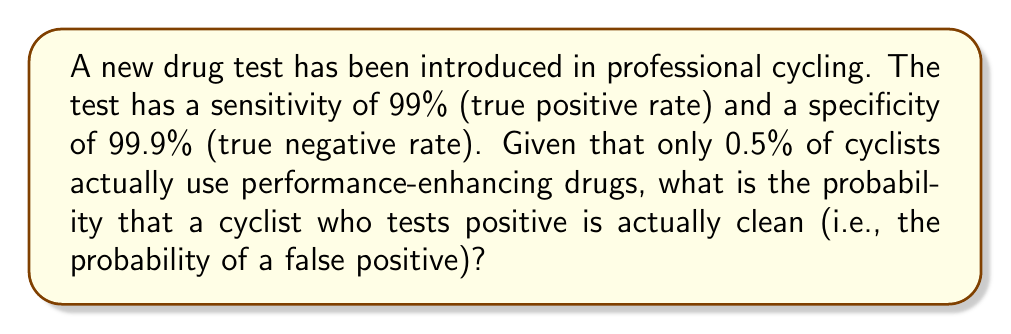Could you help me with this problem? To solve this problem, we'll use Bayes' theorem. Let's define our events:

A: The cyclist is actually using performance-enhancing drugs
B: The test result is positive

We want to find P(not A | B), which is the probability that a cyclist is clean given a positive test result.

Given:
P(A) = 0.005 (0.5% of cyclists use drugs)
P(not A) = 1 - 0.005 = 0.995
P(B|A) = 0.99 (sensitivity)
P(B|not A) = 1 - 0.999 = 0.001 (1 - specificity)

Step 1: Calculate P(B) using the law of total probability
$$P(B) = P(B|A) \cdot P(A) + P(B|not A) \cdot P(not A)$$
$$P(B) = 0.99 \cdot 0.005 + 0.001 \cdot 0.995 = 0.00495 + 0.000995 = 0.005945$$

Step 2: Apply Bayes' theorem to find P(not A | B)
$$P(not A | B) = \frac{P(B|not A) \cdot P(not A)}{P(B)}$$

$$P(not A | B) = \frac{0.001 \cdot 0.995}{0.005945} \approx 0.1674$$

Step 3: Convert to percentage
0.1674 * 100 ≈ 16.74%

Therefore, the probability of a false positive (a clean cyclist testing positive) is approximately 16.74%.
Answer: 16.74% 